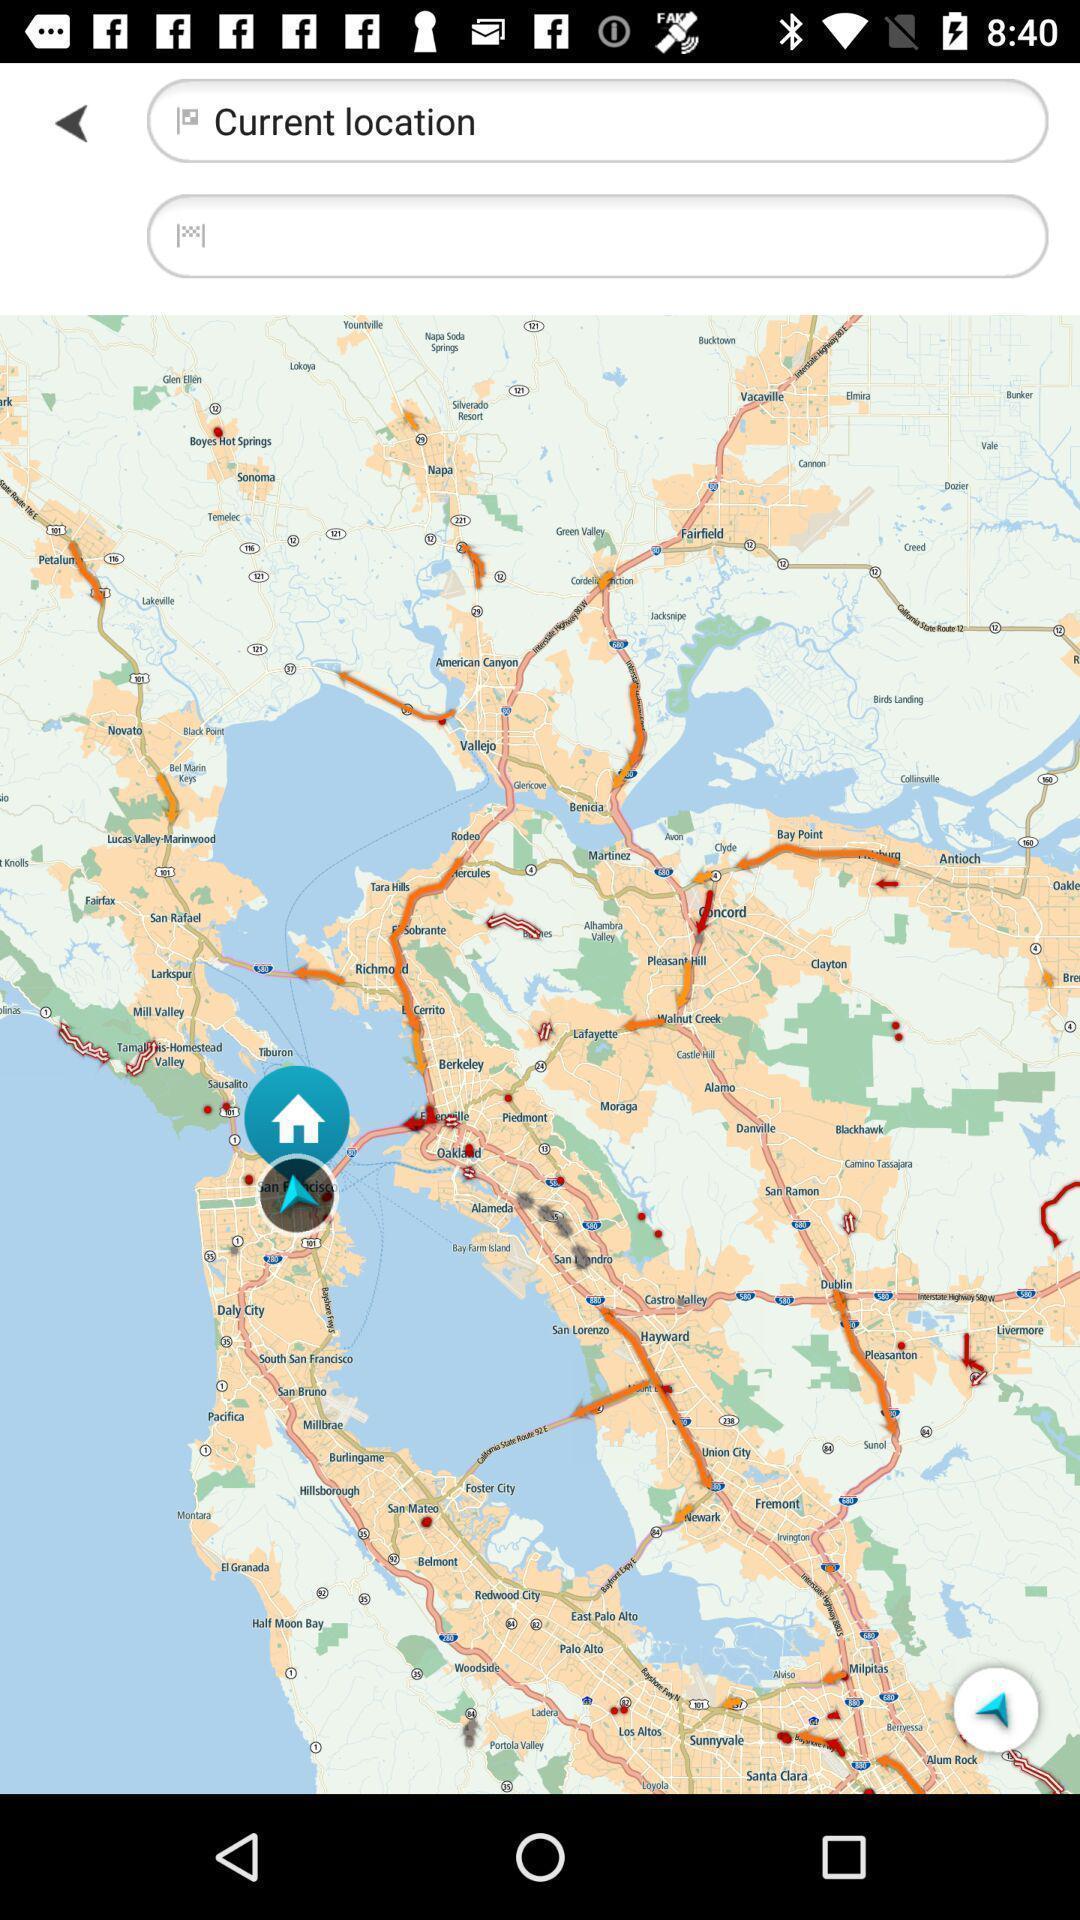Please provide a description for this image. Page displaying the current location in navigation app. 